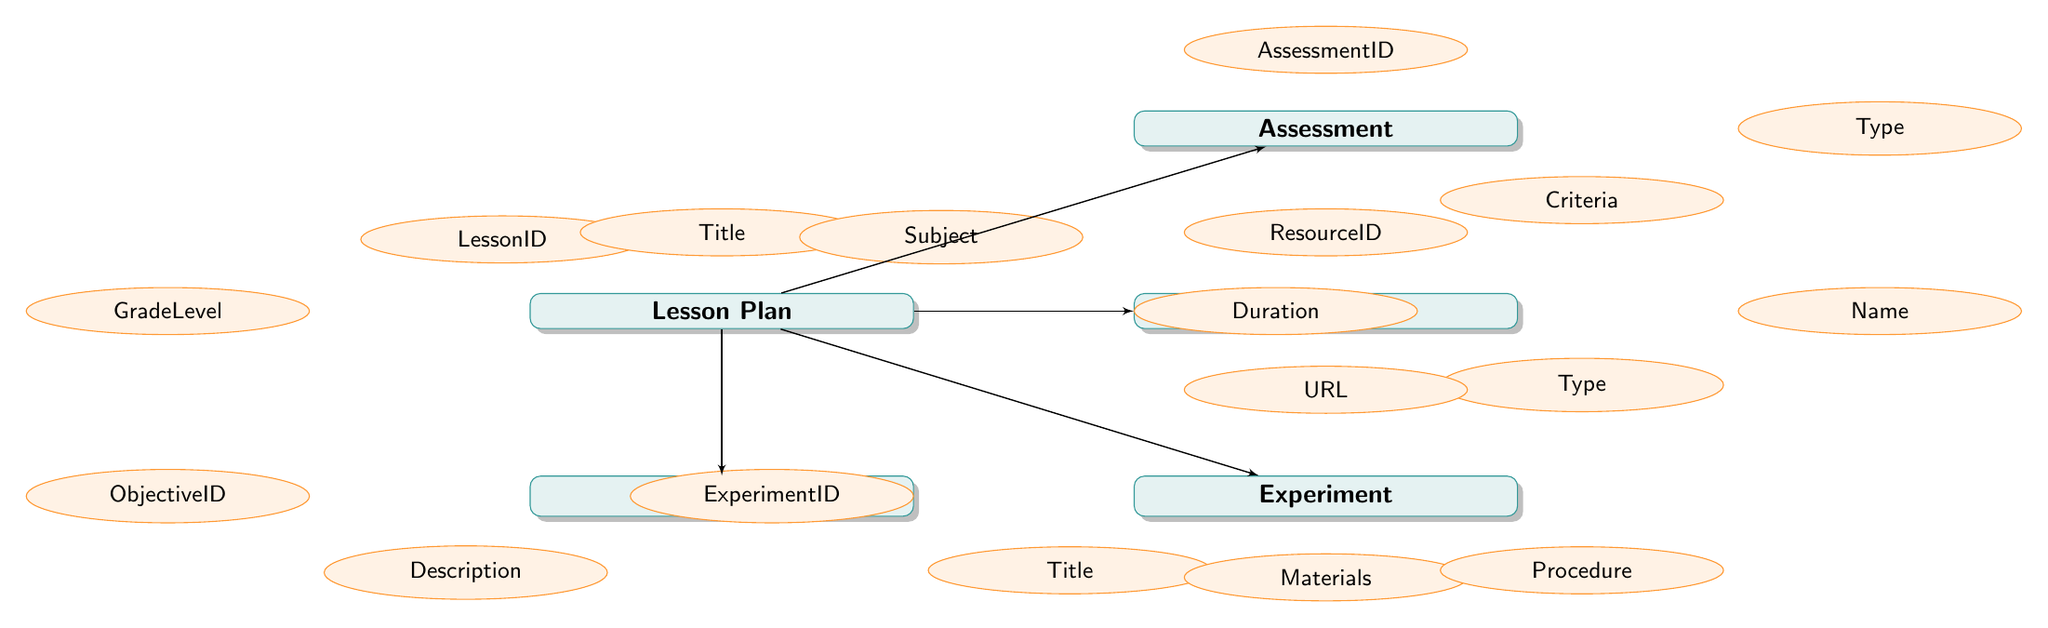What is the primary entity represented in the diagram? The primary entity is "Lesson Plan," which serves as the central node of the diagram. It is connected to four other entities (Objective, Experiment, Assessment, and Resource) that provide a comprehensive structure surrounding the lesson plan.
Answer: Lesson Plan How many attributes does the "Experiment" entity have? The "Experiment" entity has four attributes: ExperimentID, Title, Materials, and Procedure. These attributes detail the components related to each experiment associated with a lesson plan.
Answer: 4 What is the relationship between "Lesson Plan" and "Assessment"? The relationship shows that the "Assessment" is related to the "Lesson Plan," indicating that each assessment is designed to evaluate one specific lesson plan. This direct connection highlights the importance of assessment in the lesson planning process.
Answer: One-to-Many Which entity contains a "Description" attribute? The "Objective" entity contains the "Description" attribute. This attribute specifies the goal or intent for the lesson in relation to the overall lesson plan.
Answer: Objective What is the URL attribute associated with which entity? The "URL" attribute is associated with the "Resource" entity. This attribute provides a link to additional resources that can support the lesson plan, such as external websites or documents.
Answer: Resource Identify one type of assessment that might be included in the "Assessment" entity. While the specific types are not detailed in the diagram itself, typically "Assessment" could include formative, summative, or diagnostic assessments. These types reflect various methods of evaluating student understanding related to the lessons.
Answer: Type If there are two objectives linked to a lesson, how many "ObjectiveID" entries would be present? If there are two objectives linked to a single lesson plan, there would be two separate "ObjectiveID" entries in the "Objective" entity. Each objective will thereby have a unique identifier to distinguish it from other objectives.
Answer: 2 Which entity has the least number of attributes? The "Assessment" entity has three attributes: AssessmentID, Type, and Criteria. Compared to "Lesson Plan," which has five, and "Experiment," which has four, "Assessment" is the entity with the least number of attributes.
Answer: Assessment 